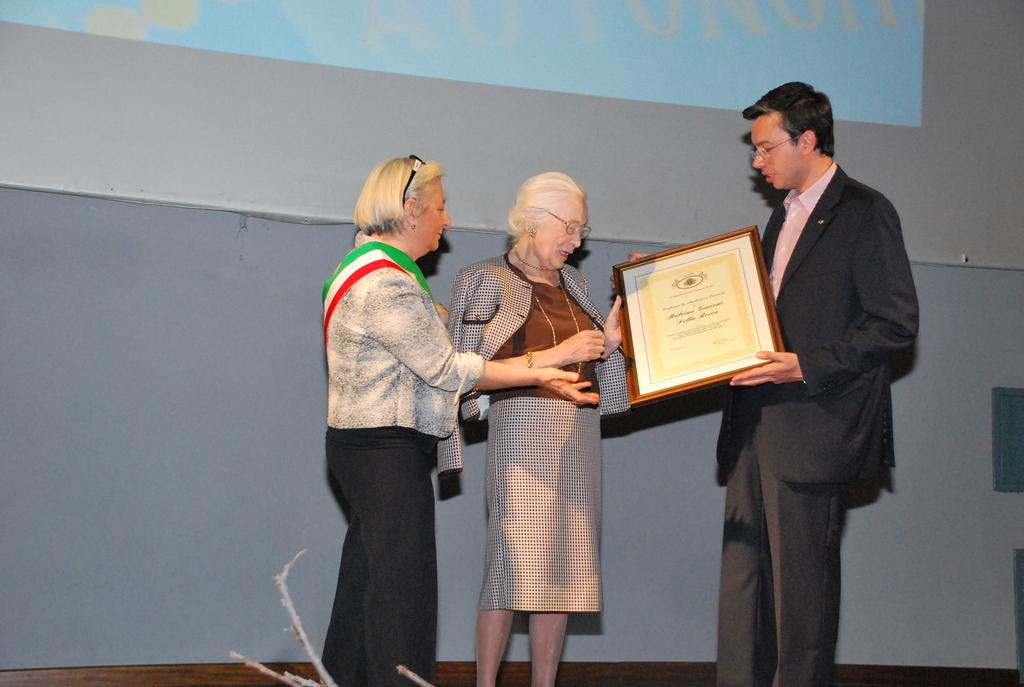What are the two people in the image holding? The two people in the image are holding an award. Who else is present in the image? There is another person beside them. What can be seen in the background of the image? There is a screen visible in the background of the image. How many pizzas are being served in the image? There are no pizzas present in the image. Is the quicksand visible in the image? There is no quicksand present in the image. 